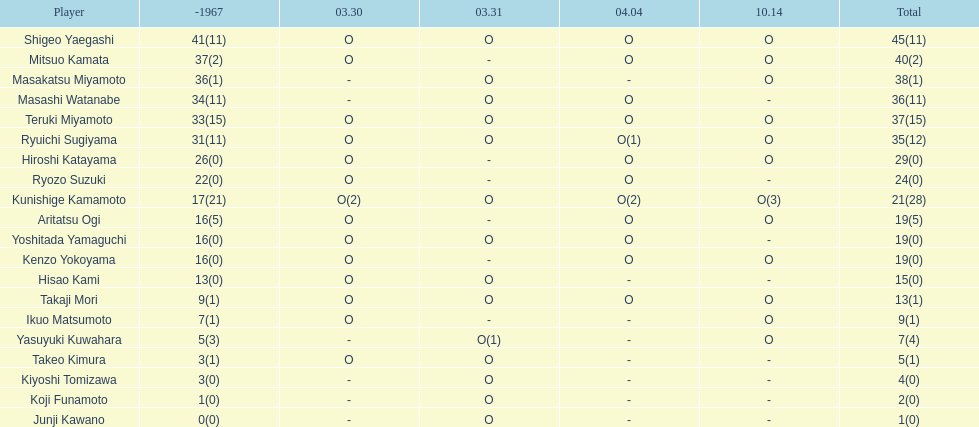Total appearances by masakatsu miyamoto? 38. 